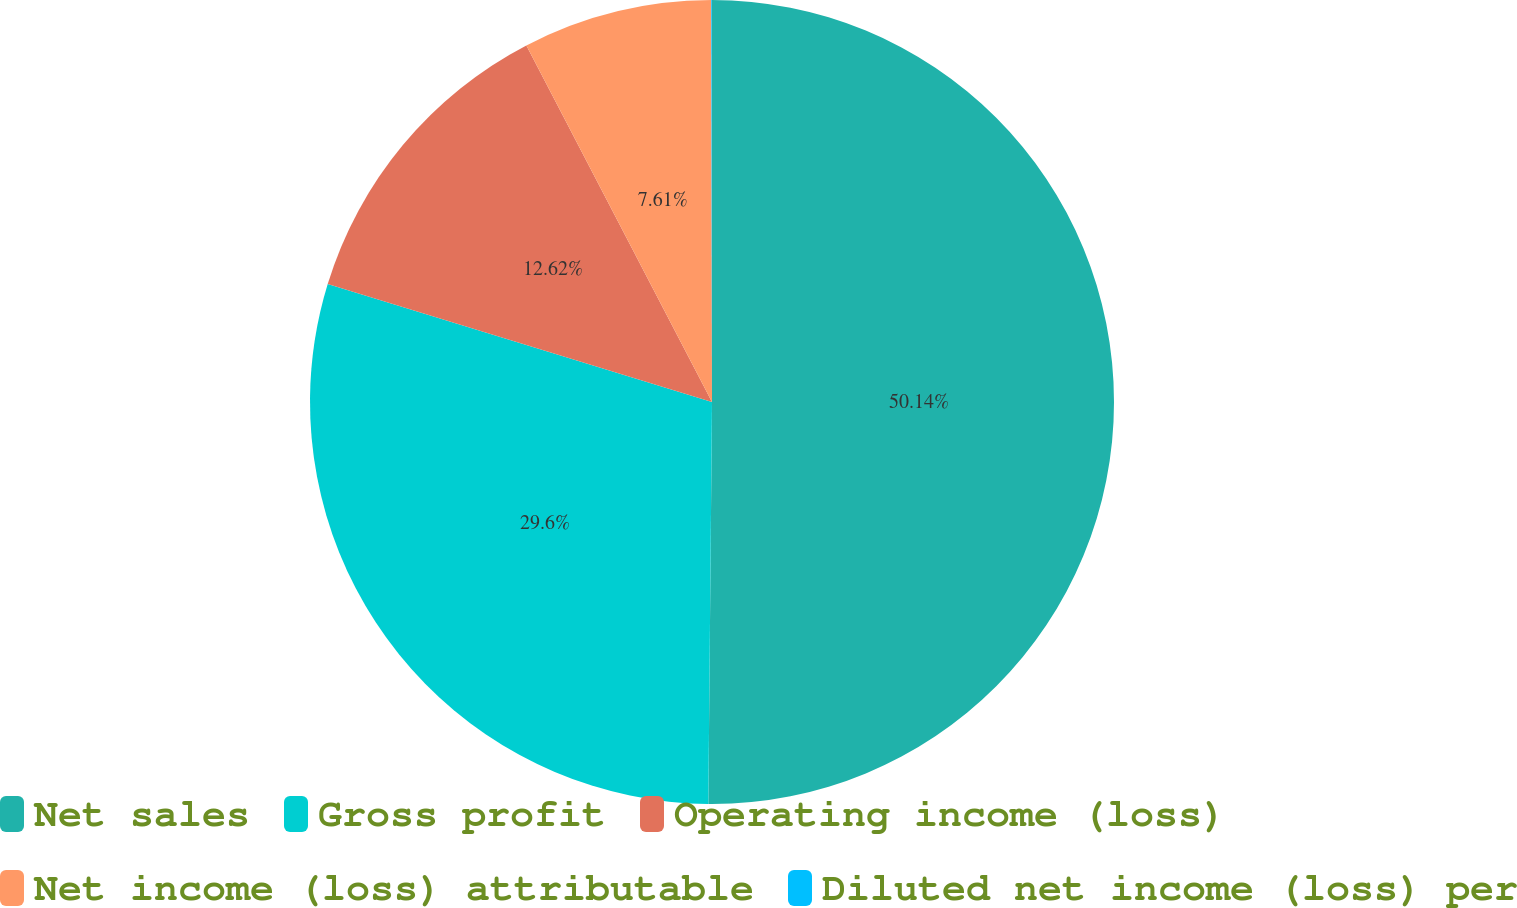Convert chart to OTSL. <chart><loc_0><loc_0><loc_500><loc_500><pie_chart><fcel>Net sales<fcel>Gross profit<fcel>Operating income (loss)<fcel>Net income (loss) attributable<fcel>Diluted net income (loss) per<nl><fcel>50.15%<fcel>29.6%<fcel>12.62%<fcel>7.61%<fcel>0.03%<nl></chart> 